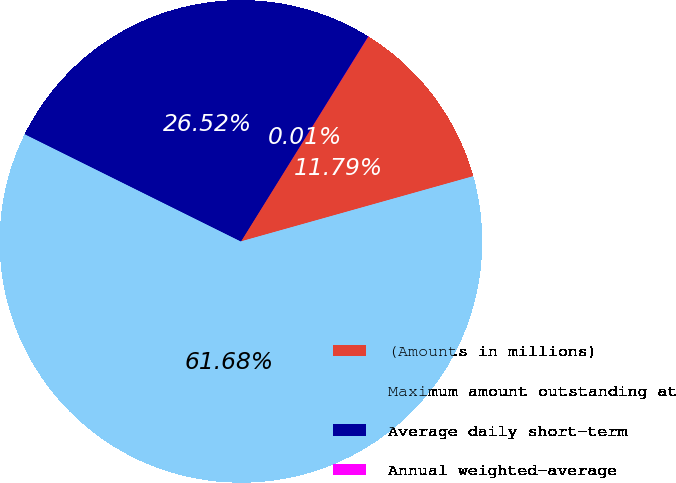Convert chart. <chart><loc_0><loc_0><loc_500><loc_500><pie_chart><fcel>(Amounts in millions)<fcel>Maximum amount outstanding at<fcel>Average daily short-term<fcel>Annual weighted-average<nl><fcel>11.79%<fcel>61.69%<fcel>26.52%<fcel>0.01%<nl></chart> 